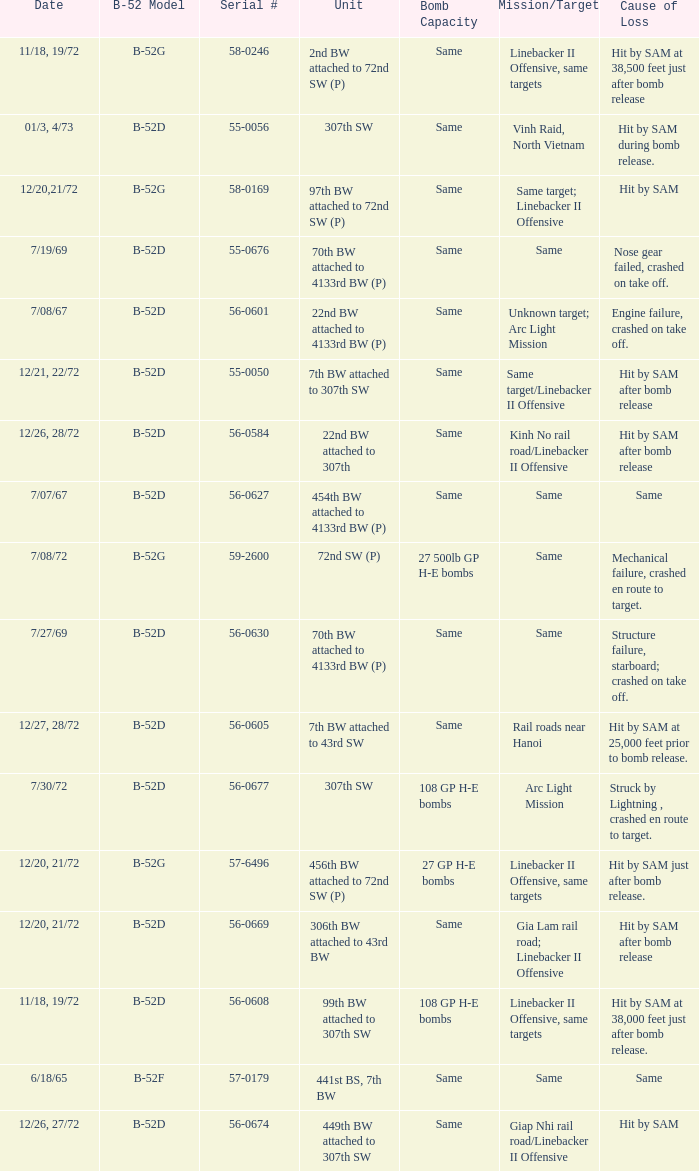Could you parse the entire table? {'header': ['Date', 'B-52 Model', 'Serial #', 'Unit', 'Bomb Capacity', 'Mission/Target', 'Cause of Loss'], 'rows': [['11/18, 19/72', 'B-52G', '58-0246', '2nd BW attached to 72nd SW (P)', 'Same', 'Linebacker II Offensive, same targets', 'Hit by SAM at 38,500 feet just after bomb release'], ['01/3, 4/73', 'B-52D', '55-0056', '307th SW', 'Same', 'Vinh Raid, North Vietnam', 'Hit by SAM during bomb release.'], ['12/20,21/72', 'B-52G', '58-0169', '97th BW attached to 72nd SW (P)', 'Same', 'Same target; Linebacker II Offensive', 'Hit by SAM'], ['7/19/69', 'B-52D', '55-0676', '70th BW attached to 4133rd BW (P)', 'Same', 'Same', 'Nose gear failed, crashed on take off.'], ['7/08/67', 'B-52D', '56-0601', '22nd BW attached to 4133rd BW (P)', 'Same', 'Unknown target; Arc Light Mission', 'Engine failure, crashed on take off.'], ['12/21, 22/72', 'B-52D', '55-0050', '7th BW attached to 307th SW', 'Same', 'Same target/Linebacker II Offensive', 'Hit by SAM after bomb release'], ['12/26, 28/72', 'B-52D', '56-0584', '22nd BW attached to 307th', 'Same', 'Kinh No rail road/Linebacker II Offensive', 'Hit by SAM after bomb release'], ['7/07/67', 'B-52D', '56-0627', '454th BW attached to 4133rd BW (P)', 'Same', 'Same', 'Same'], ['7/08/72', 'B-52G', '59-2600', '72nd SW (P)', '27 500lb GP H-E bombs', 'Same', 'Mechanical failure, crashed en route to target.'], ['7/27/69', 'B-52D', '56-0630', '70th BW attached to 4133rd BW (P)', 'Same', 'Same', 'Structure failure, starboard; crashed on take off.'], ['12/27, 28/72', 'B-52D', '56-0605', '7th BW attached to 43rd SW', 'Same', 'Rail roads near Hanoi', 'Hit by SAM at 25,000 feet prior to bomb release.'], ['7/30/72', 'B-52D', '56-0677', '307th SW', '108 GP H-E bombs', 'Arc Light Mission', 'Struck by Lightning , crashed en route to target.'], ['12/20, 21/72', 'B-52G', '57-6496', '456th BW attached to 72nd SW (P)', '27 GP H-E bombs', 'Linebacker II Offensive, same targets', 'Hit by SAM just after bomb release.'], ['12/20, 21/72', 'B-52D', '56-0669', '306th BW attached to 43rd BW', 'Same', 'Gia Lam rail road; Linebacker II Offensive', 'Hit by SAM after bomb release'], ['11/18, 19/72', 'B-52D', '56-0608', '99th BW attached to 307th SW', '108 GP H-E bombs', 'Linebacker II Offensive, same targets', 'Hit by SAM at 38,000 feet just after bomb release.'], ['6/18/65', 'B-52F', '57-0179', '441st BS, 7th BW', 'Same', 'Same', 'Same'], ['12/26, 27/72', 'B-52D', '56-0674', '449th BW attached to 307th SW', 'Same', 'Giap Nhi rail road/Linebacker II Offensive', 'Hit by SAM']]} When 441st bs, 7th bw is the unit what is the b-52 model? B-52F. 